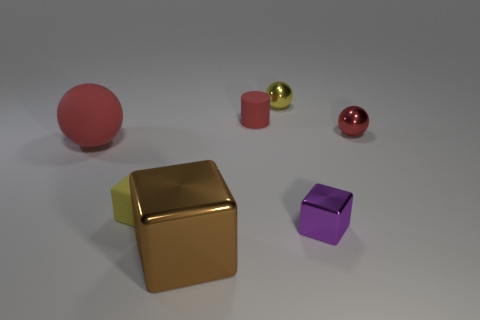Subtract all big blocks. How many blocks are left? 2 Subtract 2 balls. How many balls are left? 1 Add 1 big yellow objects. How many objects exist? 8 Subtract all yellow balls. How many balls are left? 2 Subtract all cylinders. How many objects are left? 6 Subtract all red spheres. Subtract all spheres. How many objects are left? 2 Add 3 matte balls. How many matte balls are left? 4 Add 7 cubes. How many cubes exist? 10 Subtract 0 cyan cubes. How many objects are left? 7 Subtract all brown cylinders. Subtract all brown blocks. How many cylinders are left? 1 